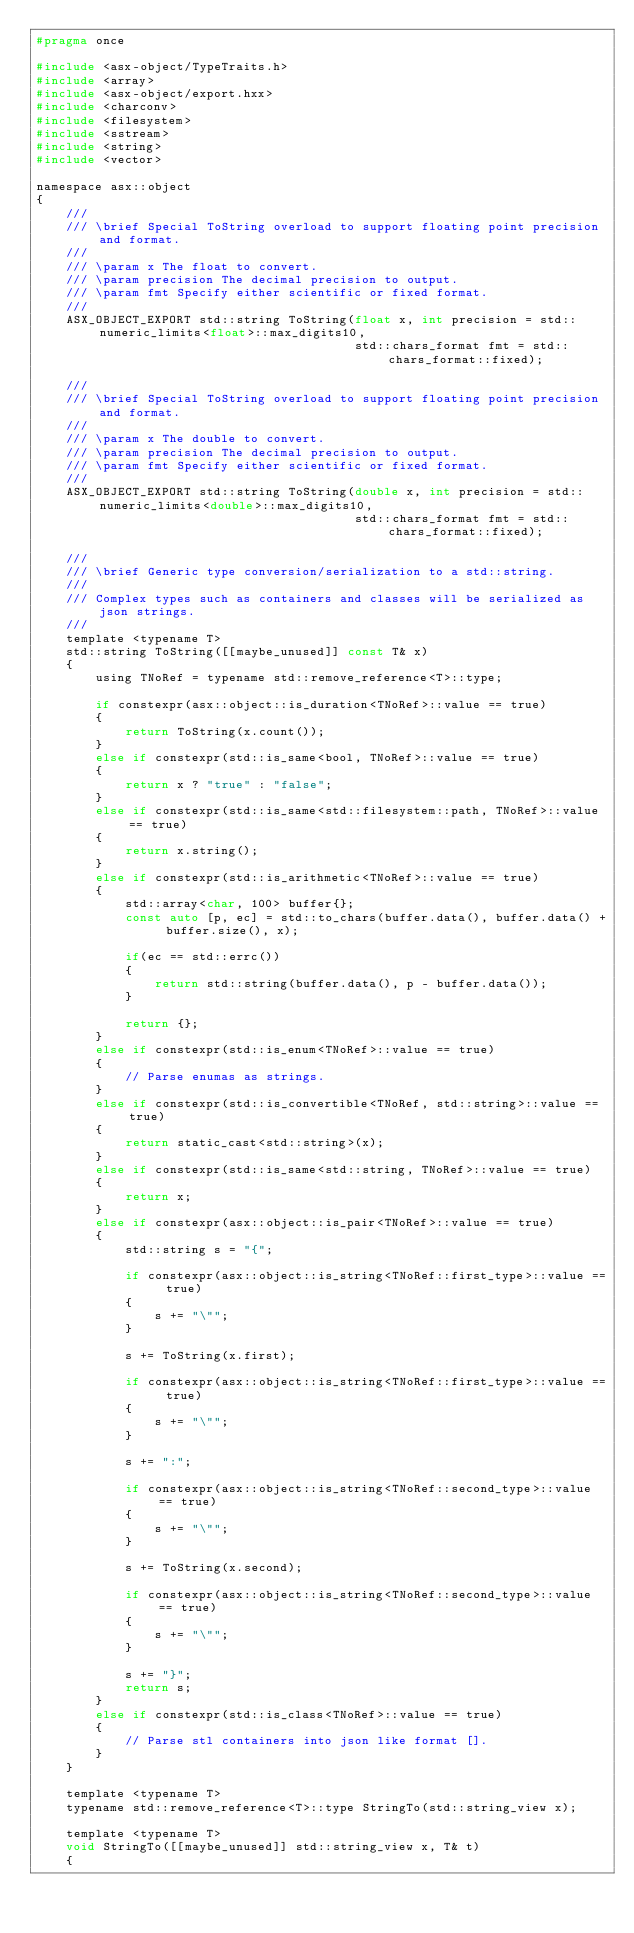<code> <loc_0><loc_0><loc_500><loc_500><_C_>#pragma once

#include <asx-object/TypeTraits.h>
#include <array>
#include <asx-object/export.hxx>
#include <charconv>
#include <filesystem>
#include <sstream>
#include <string>
#include <vector>

namespace asx::object
{
	///
	///	\brief Special ToString overload to support floating point precision and format.
	///
	///	\param x The float to convert.
	///	\param precision The decimal precision to output.
	///	\param fmt Specify either scientific or fixed format.
	///
	ASX_OBJECT_EXPORT std::string ToString(float x, int precision = std::numeric_limits<float>::max_digits10,
										   std::chars_format fmt = std::chars_format::fixed);

	///
	///	\brief Special ToString overload to support floating point precision and format.
	///
	///	\param x The double to convert.
	///	\param precision The decimal precision to output.
	///	\param fmt Specify either scientific or fixed format.
	///
	ASX_OBJECT_EXPORT std::string ToString(double x, int precision = std::numeric_limits<double>::max_digits10,
										   std::chars_format fmt = std::chars_format::fixed);

	///
	///	\brief Generic type conversion/serialization to a std::string.
	///
	///	Complex types such as containers and classes will be serialized as json strings.
	///
	template <typename T>
	std::string ToString([[maybe_unused]] const T& x)
	{
		using TNoRef = typename std::remove_reference<T>::type;

		if constexpr(asx::object::is_duration<TNoRef>::value == true)
		{
			return ToString(x.count());
		}
		else if constexpr(std::is_same<bool, TNoRef>::value == true)
		{
			return x ? "true" : "false";
		}
		else if constexpr(std::is_same<std::filesystem::path, TNoRef>::value == true)
		{
			return x.string();
		}
		else if constexpr(std::is_arithmetic<TNoRef>::value == true)
		{
			std::array<char, 100> buffer{};
			const auto [p, ec] = std::to_chars(buffer.data(), buffer.data() + buffer.size(), x);

			if(ec == std::errc())
			{
				return std::string(buffer.data(), p - buffer.data());
			}

			return {};
		}
		else if constexpr(std::is_enum<TNoRef>::value == true)
		{
			// Parse enumas as strings.
		}
		else if constexpr(std::is_convertible<TNoRef, std::string>::value == true)
		{
			return static_cast<std::string>(x);
		}
		else if constexpr(std::is_same<std::string, TNoRef>::value == true)
		{
			return x;
		}
		else if constexpr(asx::object::is_pair<TNoRef>::value == true)
		{
			std::string s = "{";

			if constexpr(asx::object::is_string<TNoRef::first_type>::value == true)
			{
				s += "\"";
			}

			s += ToString(x.first);

			if constexpr(asx::object::is_string<TNoRef::first_type>::value == true)
			{
				s += "\"";
			}

			s += ":";

			if constexpr(asx::object::is_string<TNoRef::second_type>::value == true)
			{
				s += "\"";
			}

			s += ToString(x.second);

			if constexpr(asx::object::is_string<TNoRef::second_type>::value == true)
			{
				s += "\"";
			}

			s += "}";
			return s;
		}
		else if constexpr(std::is_class<TNoRef>::value == true)
		{
			// Parse stl containers into json like format [].
		}
	}

	template <typename T>
	typename std::remove_reference<T>::type StringTo(std::string_view x);

	template <typename T>
	void StringTo([[maybe_unused]] std::string_view x, T& t)
	{</code> 